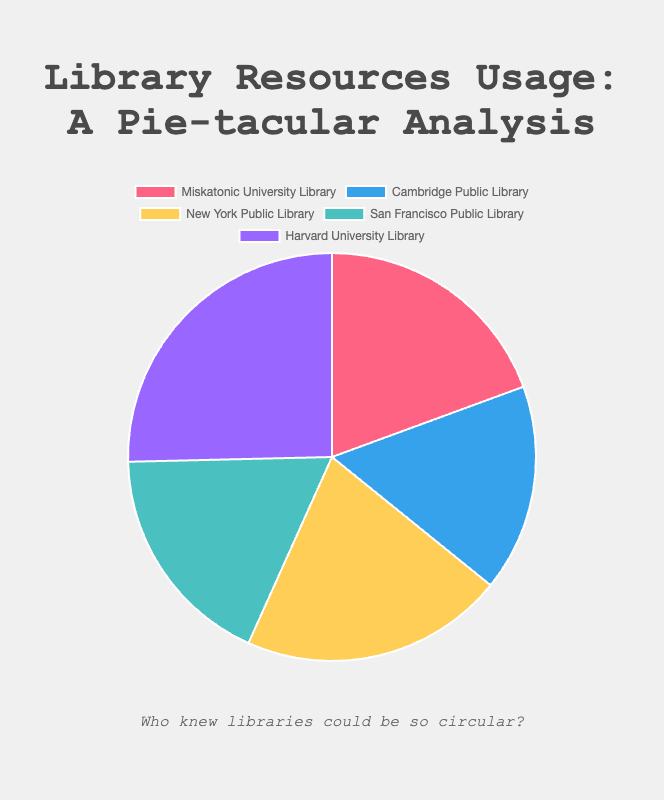What is the total percentage of resources used for research at Miskatonic University Library and Harvard University Library combined? Add the research usage percentages for Miskatonic University Library (65%) and Harvard University Library (85%). The total is 65% + 85% = 150%.
Answer: 150% Which library has the highest percentage of resources used for research? By examining the figure, Harvard University Library has the highest percentage with 85%.
Answer: Harvard University Library Which library has the smallest proportion of resources used for research? According to the pie chart, Cambridge Public Library has the smallest proportion with 55%.
Answer: Cambridge Public Library By what percentage is the research usage at New York Public Library greater than at San Francisco Public Library? The research usage at New York Public Library is 70%, and at San Francisco Public Library it is 60%. The difference is 70% - 60% = 10%.
Answer: 10% What is the average research usage percentage across all libraries? Add the research usage for all libraries: 65% + 55% + 70% + 60% + 85% which equals 335%. Divide by the number of libraries (5). The average is 335% / 5 = 67%.
Answer: 67% Which library has the smallest general browsing percentage and what is the value? The library with the smallest general browsing percentage is Harvard University Library with 15%.
Answer: Harvard University Library, 15% What is the combined percentage of general browsing resources for Miskatonic University Library and San Francisco Public Library? Add the general browsing percentages for Miskatonic University Library (35%) and San Francisco Public Library (40%). The total is 35% + 40% = 75%.
Answer: 75% Which library has a higher research usage percentage: Cambridge Public Library or San Francisco Public Library? Cambridge Public Library has 55% research usage while San Francisco Public Library has 60%. Therefore, San Francisco Public Library has a higher percentage.
Answer: San Francisco Public Library By what percentage is the general browsing usage at Cambridge Public Library greater than at Harvard University Library? Cambridge Public Library has 45% general browsing and Harvard University Library has 15%. The difference is 45% - 15% = 30%.
Answer: 30% If the research usage at New York Public Library was split equally into two new categories, what would be the percentage for each new category? The current research usage is 70%. Splitting this equally into two categories would result in 70% / 2 = 35% for each new category.
Answer: 35% 